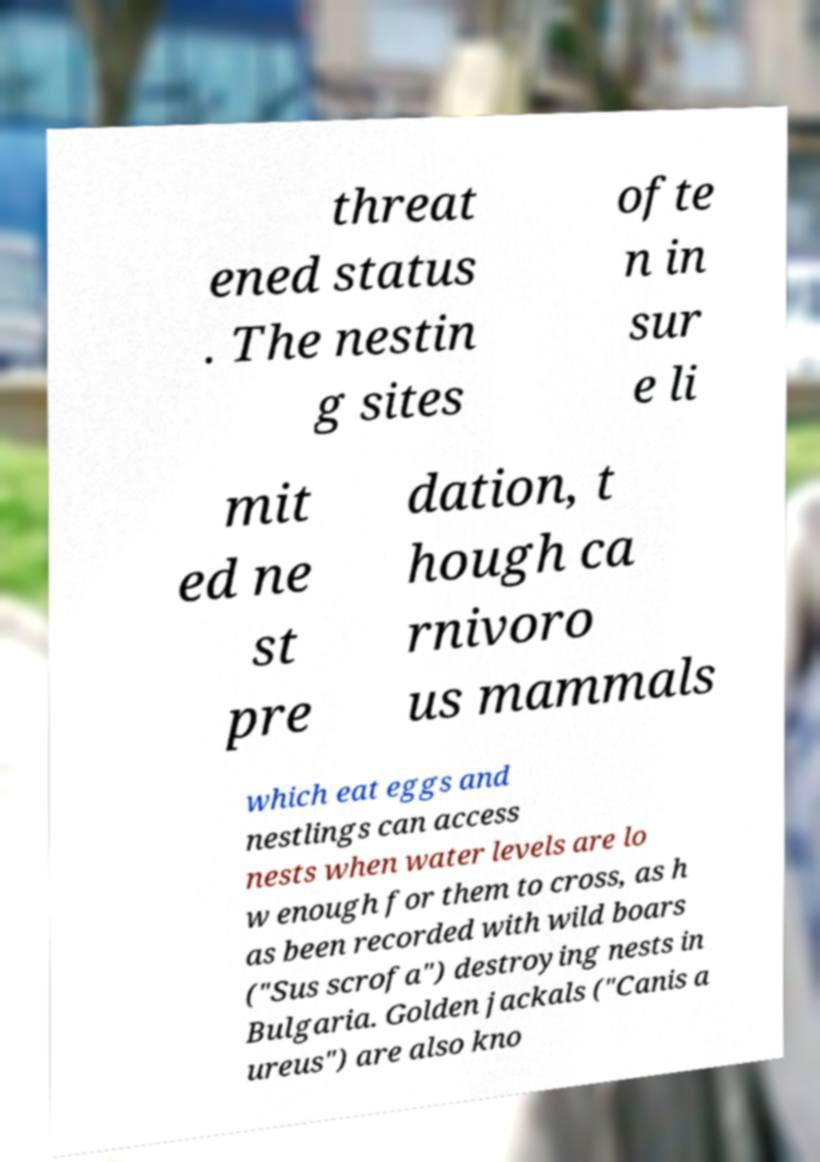Please identify and transcribe the text found in this image. threat ened status . The nestin g sites ofte n in sur e li mit ed ne st pre dation, t hough ca rnivoro us mammals which eat eggs and nestlings can access nests when water levels are lo w enough for them to cross, as h as been recorded with wild boars ("Sus scrofa") destroying nests in Bulgaria. Golden jackals ("Canis a ureus") are also kno 